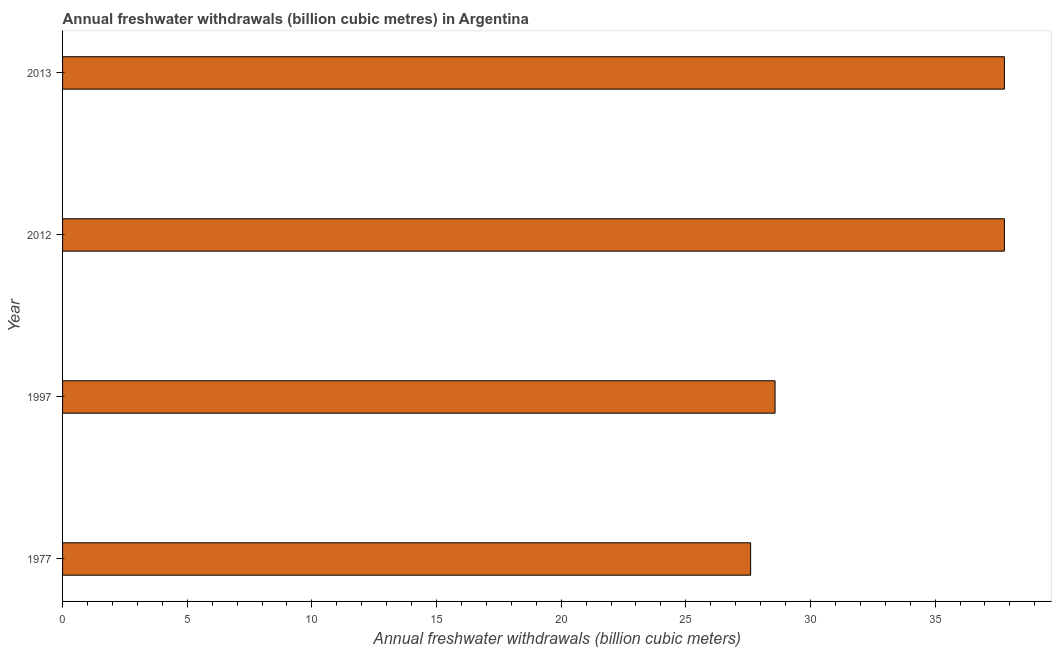Does the graph contain any zero values?
Keep it short and to the point. No. What is the title of the graph?
Provide a succinct answer. Annual freshwater withdrawals (billion cubic metres) in Argentina. What is the label or title of the X-axis?
Provide a succinct answer. Annual freshwater withdrawals (billion cubic meters). What is the label or title of the Y-axis?
Ensure brevity in your answer.  Year. What is the annual freshwater withdrawals in 1977?
Your answer should be compact. 27.6. Across all years, what is the maximum annual freshwater withdrawals?
Ensure brevity in your answer.  37.78. Across all years, what is the minimum annual freshwater withdrawals?
Your answer should be compact. 27.6. In which year was the annual freshwater withdrawals minimum?
Make the answer very short. 1977. What is the sum of the annual freshwater withdrawals?
Your answer should be very brief. 131.74. What is the difference between the annual freshwater withdrawals in 1977 and 2013?
Your answer should be compact. -10.18. What is the average annual freshwater withdrawals per year?
Ensure brevity in your answer.  32.94. What is the median annual freshwater withdrawals?
Give a very brief answer. 33.18. In how many years, is the annual freshwater withdrawals greater than 36 billion cubic meters?
Your answer should be compact. 2. Do a majority of the years between 1977 and 1997 (inclusive) have annual freshwater withdrawals greater than 38 billion cubic meters?
Make the answer very short. No. What is the ratio of the annual freshwater withdrawals in 1977 to that in 1997?
Provide a short and direct response. 0.97. Is the annual freshwater withdrawals in 1997 less than that in 2012?
Offer a terse response. Yes. What is the difference between the highest and the lowest annual freshwater withdrawals?
Your answer should be very brief. 10.18. In how many years, is the annual freshwater withdrawals greater than the average annual freshwater withdrawals taken over all years?
Ensure brevity in your answer.  2. How many bars are there?
Your answer should be compact. 4. What is the Annual freshwater withdrawals (billion cubic meters) in 1977?
Give a very brief answer. 27.6. What is the Annual freshwater withdrawals (billion cubic meters) of 1997?
Keep it short and to the point. 28.58. What is the Annual freshwater withdrawals (billion cubic meters) in 2012?
Your answer should be very brief. 37.78. What is the Annual freshwater withdrawals (billion cubic meters) of 2013?
Provide a short and direct response. 37.78. What is the difference between the Annual freshwater withdrawals (billion cubic meters) in 1977 and 1997?
Make the answer very short. -0.98. What is the difference between the Annual freshwater withdrawals (billion cubic meters) in 1977 and 2012?
Give a very brief answer. -10.18. What is the difference between the Annual freshwater withdrawals (billion cubic meters) in 1977 and 2013?
Your response must be concise. -10.18. What is the difference between the Annual freshwater withdrawals (billion cubic meters) in 1997 and 2012?
Make the answer very short. -9.2. What is the ratio of the Annual freshwater withdrawals (billion cubic meters) in 1977 to that in 1997?
Make the answer very short. 0.97. What is the ratio of the Annual freshwater withdrawals (billion cubic meters) in 1977 to that in 2012?
Provide a short and direct response. 0.73. What is the ratio of the Annual freshwater withdrawals (billion cubic meters) in 1977 to that in 2013?
Your answer should be compact. 0.73. What is the ratio of the Annual freshwater withdrawals (billion cubic meters) in 1997 to that in 2012?
Give a very brief answer. 0.76. What is the ratio of the Annual freshwater withdrawals (billion cubic meters) in 1997 to that in 2013?
Provide a short and direct response. 0.76. What is the ratio of the Annual freshwater withdrawals (billion cubic meters) in 2012 to that in 2013?
Provide a short and direct response. 1. 